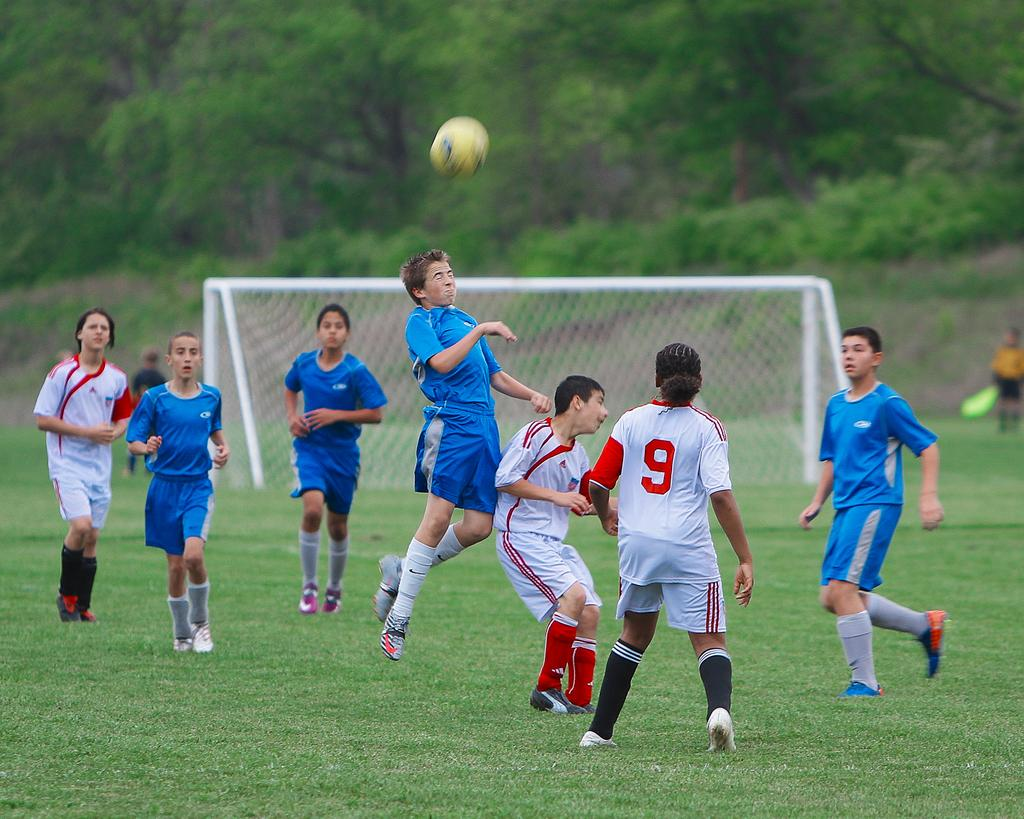What are the people in the image doing? The people in the image are players, which suggests they are playing a game or sport. Where are the players located? The players are on a ground, which indicates an outdoor or sports field setting. What is the main goal or objective of the game being played? There is a football goal net in the image, so the game being played is likely football or soccer. What can be seen in the background of the image? There are trees visible in the image, which adds to the outdoor setting. What is the essential piece of equipment needed for the game? There is a ball in the image, which is necessary for playing football or soccer. Reasoning: Let' Let's think step by step in order to produce the conversation. We start by identifying the main subjects in the image, which are the players. Then, we describe their location and the game they are playing based on the presence of a football goal net. Next, we mention the background elements, such as trees, to give a sense of the setting. Finally, we identify the essential equipment needed for the game, which is the ball. Absurd Question/Answer: What type of cast can be seen on the player's arm in the image? There is no cast visible on any player's arm in the image. How does the grip of the players on the ball affect the acoustics of the game? There is no mention of the players' grip on the ball or any acoustics in the image, so this question cannot be answered definitively. What is the person in the image doing? The person in the image is sitting on a chair and holding a book, which suggests they are reading or studying. What object is next to the chair? There is a table next to the chair. What is on the table? There is a lamp on the table. What can be seen in the background of the image? The background of the image is a wall. Reasoning: Let's think step by step in order to produce the conversation. We start by identifying the main subject in the image, which is the person sitting on a chair. Then, we describe their activity, which is holding a book. Next, we mention the objects next to the chair, such as the table and lamp. Finally, we describe the background elements, which in this case is a wall. Absurd Question/Answer: Can you see a parrot sitting on the trampoline in the image? There 